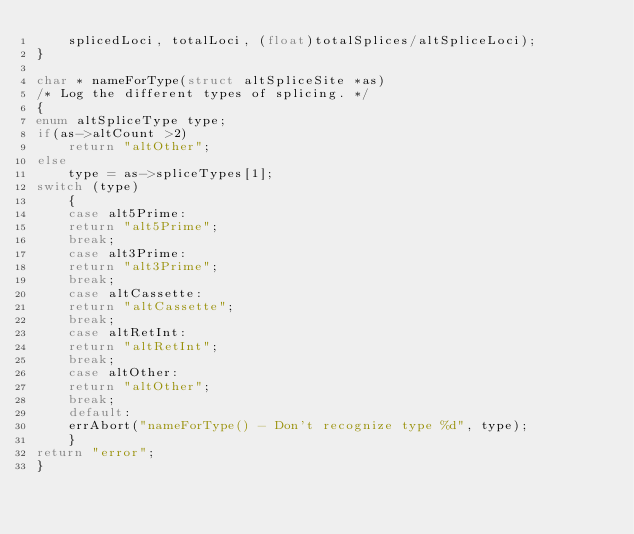<code> <loc_0><loc_0><loc_500><loc_500><_C_>	splicedLoci, totalLoci, (float)totalSplices/altSpliceLoci);
}

char * nameForType(struct altSpliceSite *as)
/* Log the different types of splicing. */
{
enum altSpliceType type;
if(as->altCount >2)
    return "altOther";
else
    type = as->spliceTypes[1];
switch (type) 
    {
    case alt5Prime:
	return "alt5Prime";
	break;
    case alt3Prime: 
	return "alt3Prime";
	break;
    case altCassette:
	return "altCassette";
	break;
    case altRetInt:
	return "altRetInt";
	break;
    case altOther:
	return "altOther";
	break;
    default:
	errAbort("nameForType() - Don't recognize type %d", type);
    }
return "error";
}
</code> 